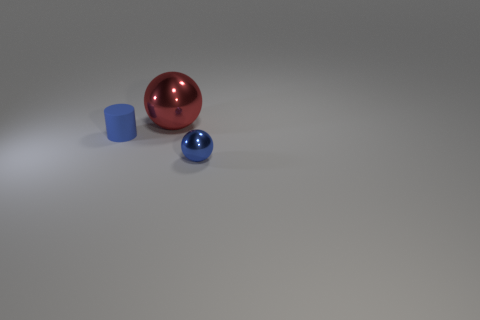Subtract all spheres. How many objects are left? 1 Add 2 brown metal spheres. How many objects exist? 5 Add 3 cyan rubber spheres. How many cyan rubber spheres exist? 3 Subtract 0 yellow balls. How many objects are left? 3 Subtract all small purple objects. Subtract all tiny spheres. How many objects are left? 2 Add 1 blue objects. How many blue objects are left? 3 